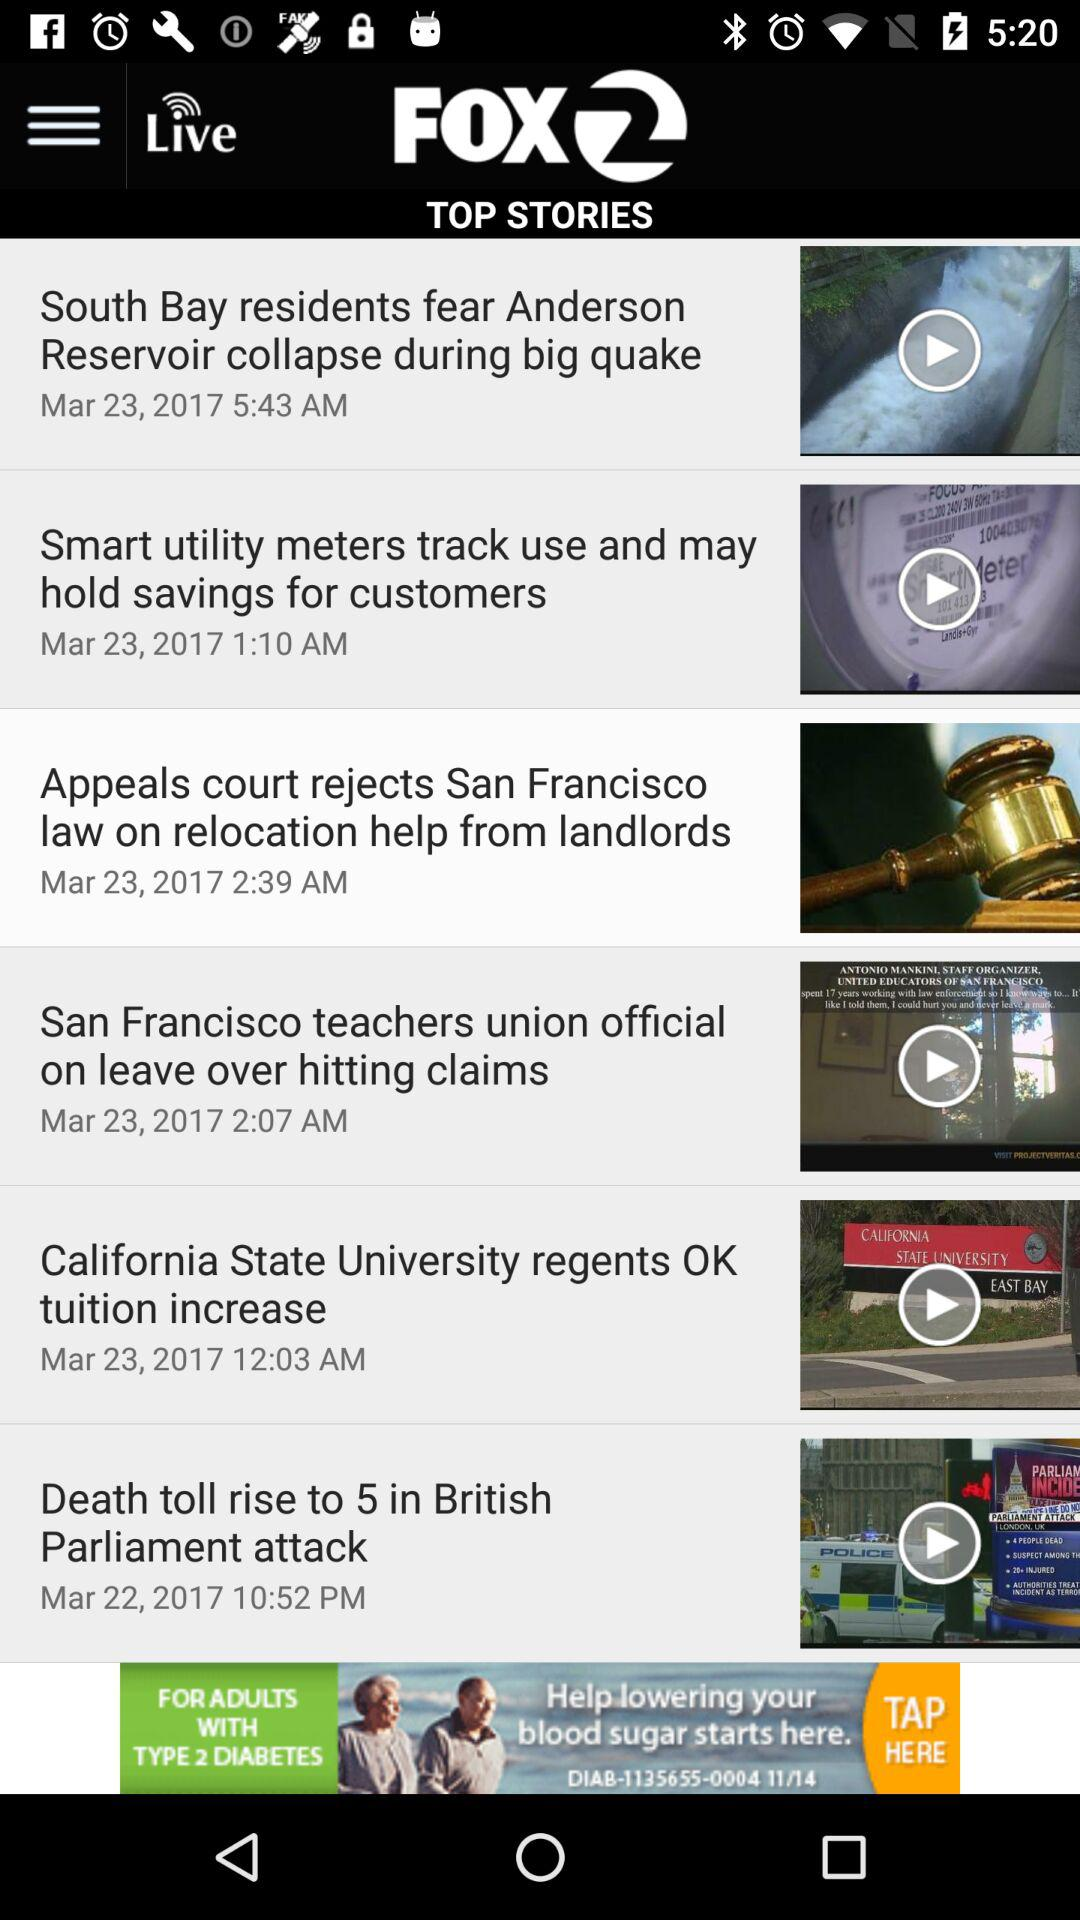What is the published date of the story "Death toll rise to 5 in British Parliament attack"? The published date is March 22, 2017. 